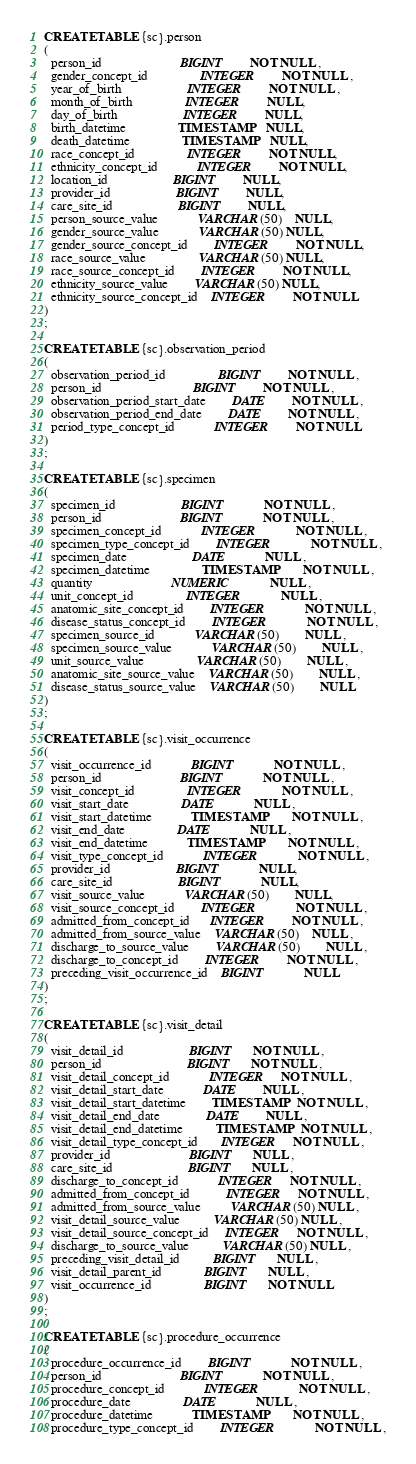<code> <loc_0><loc_0><loc_500><loc_500><_SQL_>CREATE TABLE {sc}.person
(
  person_id						BIGINT	  	NOT NULL , 
  gender_concept_id				INTEGER	  	NOT NULL ,
  year_of_birth					INTEGER	  	NOT NULL ,
  month_of_birth				INTEGER	  	NULL,
  day_of_birth					INTEGER	  	NULL,
  birth_datetime				TIMESTAMP	NULL,
  death_datetime				TIMESTAMP	NULL,
  race_concept_id				INTEGER		NOT NULL,
  ethnicity_concept_id			INTEGER	  	NOT NULL,
  location_id					BIGINT		NULL,
  provider_id					BIGINT		NULL,
  care_site_id					BIGINT		NULL,
  person_source_value			VARCHAR(50)	NULL,
  gender_source_value			VARCHAR(50) NULL,
  gender_source_concept_id	  	INTEGER		NOT NULL,
  race_source_value				VARCHAR(50) NULL,
  race_source_concept_id		INTEGER		NOT NULL,
  ethnicity_source_value		VARCHAR(50) NULL,
  ethnicity_source_concept_id	INTEGER		NOT NULL
)
;

CREATE TABLE {sc}.observation_period
(
  observation_period_id				BIGINT		NOT NULL ,
  person_id							BIGINT		NOT NULL ,
  observation_period_start_date		DATE		NOT NULL ,
  observation_period_end_date		DATE		NOT NULL ,
  period_type_concept_id			INTEGER		NOT NULL
)
;

CREATE TABLE {sc}.specimen
(
  specimen_id					BIGINT			NOT NULL ,
  person_id						BIGINT			NOT NULL ,
  specimen_concept_id			INTEGER			NOT NULL ,
  specimen_type_concept_id		INTEGER			NOT NULL ,
  specimen_date					DATE			NULL ,
  specimen_datetime				TIMESTAMP		NOT NULL ,
  quantity						NUMERIC			NULL ,
  unit_concept_id				INTEGER			NULL ,
  anatomic_site_concept_id		INTEGER			NOT NULL ,
  disease_status_concept_id		INTEGER			NOT NULL ,
  specimen_source_id			VARCHAR(50)		NULL ,
  specimen_source_value			VARCHAR(50)		NULL ,
  unit_source_value				VARCHAR(50)		NULL ,
  anatomic_site_source_value	VARCHAR(50)		NULL ,
  disease_status_source_value	VARCHAR(50)		NULL
)
;

CREATE TABLE {sc}.visit_occurrence
(
  visit_occurrence_id			BIGINT			NOT NULL ,
  person_id						BIGINT			NOT NULL ,
  visit_concept_id				INTEGER			NOT NULL ,
  visit_start_date				DATE			NULL ,
  visit_start_datetime			TIMESTAMP		NOT NULL ,
  visit_end_date				DATE			NULL ,
  visit_end_datetime			TIMESTAMP		NOT NULL ,
  visit_type_concept_id			INTEGER			NOT NULL ,
  provider_id					BIGINT			NULL,
  care_site_id					BIGINT			NULL,
  visit_source_value			VARCHAR(50)		NULL,
  visit_source_concept_id		INTEGER			NOT NULL ,
  admitted_from_concept_id      INTEGER     	NOT NULL ,   
  admitted_from_source_value    VARCHAR(50) 	NULL ,
  discharge_to_source_value		VARCHAR(50)		NULL ,
  discharge_to_concept_id		INTEGER   		NOT NULL ,
  preceding_visit_occurrence_id	BIGINT 			NULL
)
;

CREATE TABLE {sc}.visit_detail
(
  visit_detail_id                    BIGINT      NOT NULL ,
  person_id                          BIGINT      NOT NULL ,
  visit_detail_concept_id            INTEGER     NOT NULL ,
  visit_detail_start_date            DATE        NULL ,
  visit_detail_start_datetime        TIMESTAMP   NOT NULL ,
  visit_detail_end_date              DATE        NULL ,
  visit_detail_end_datetime          TIMESTAMP   NOT NULL ,
  visit_detail_type_concept_id       INTEGER     NOT NULL ,
  provider_id                        BIGINT      NULL ,
  care_site_id                       BIGINT      NULL ,
  discharge_to_concept_id            INTEGER     NOT NULL ,
  admitted_from_concept_id           INTEGER     NOT NULL , 
  admitted_from_source_value         VARCHAR(50) NULL ,
  visit_detail_source_value          VARCHAR(50) NULL ,
  visit_detail_source_concept_id     INTEGER     NOT NULL ,
  discharge_to_source_value          VARCHAR(50) NULL ,
  preceding_visit_detail_id          BIGINT      NULL ,
  visit_detail_parent_id             BIGINT      NULL ,
  visit_occurrence_id                BIGINT      NOT NULL
)
;

CREATE TABLE {sc}.procedure_occurrence
(
  procedure_occurrence_id		BIGINT			NOT NULL ,
  person_id						BIGINT			NOT NULL ,
  procedure_concept_id			INTEGER			NOT NULL ,
  procedure_date				DATE			NULL ,
  procedure_datetime			TIMESTAMP		NOT NULL ,
  procedure_type_concept_id		INTEGER			NOT NULL ,</code> 